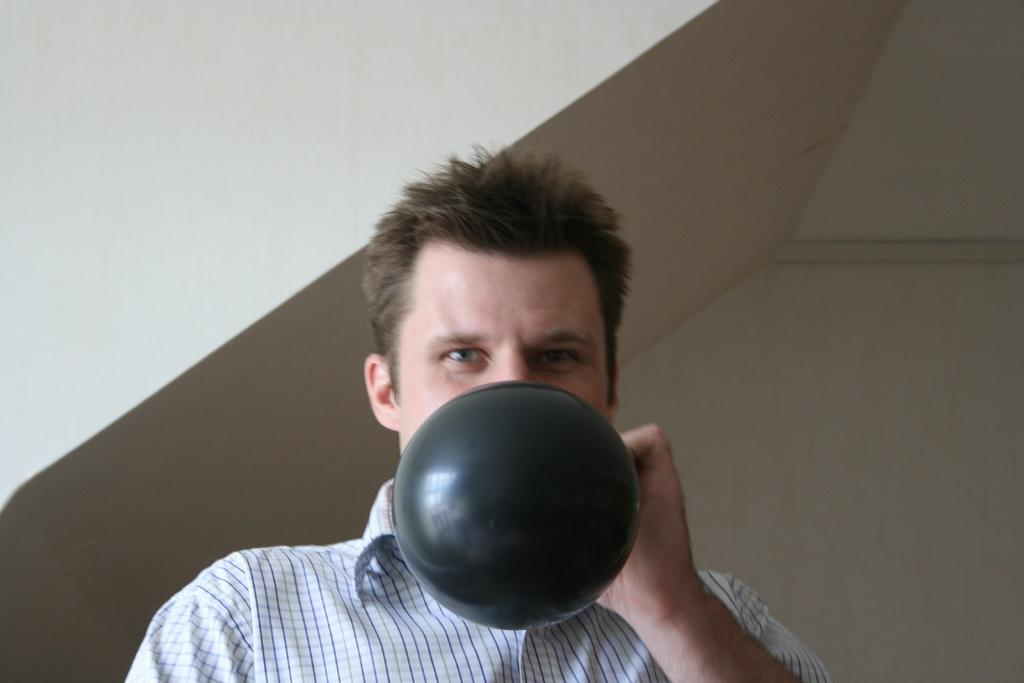What is the main subject in the foreground of the image? There is a person in the foreground of the image. What is the person doing in the image? The person is blowing a balloon. What can be seen in the background of the image? There is a wall in the background of the image. What type of string is attached to the seed in the image? There is no string or seed present in the image; it features a person blowing a balloon with a wall in the background. 